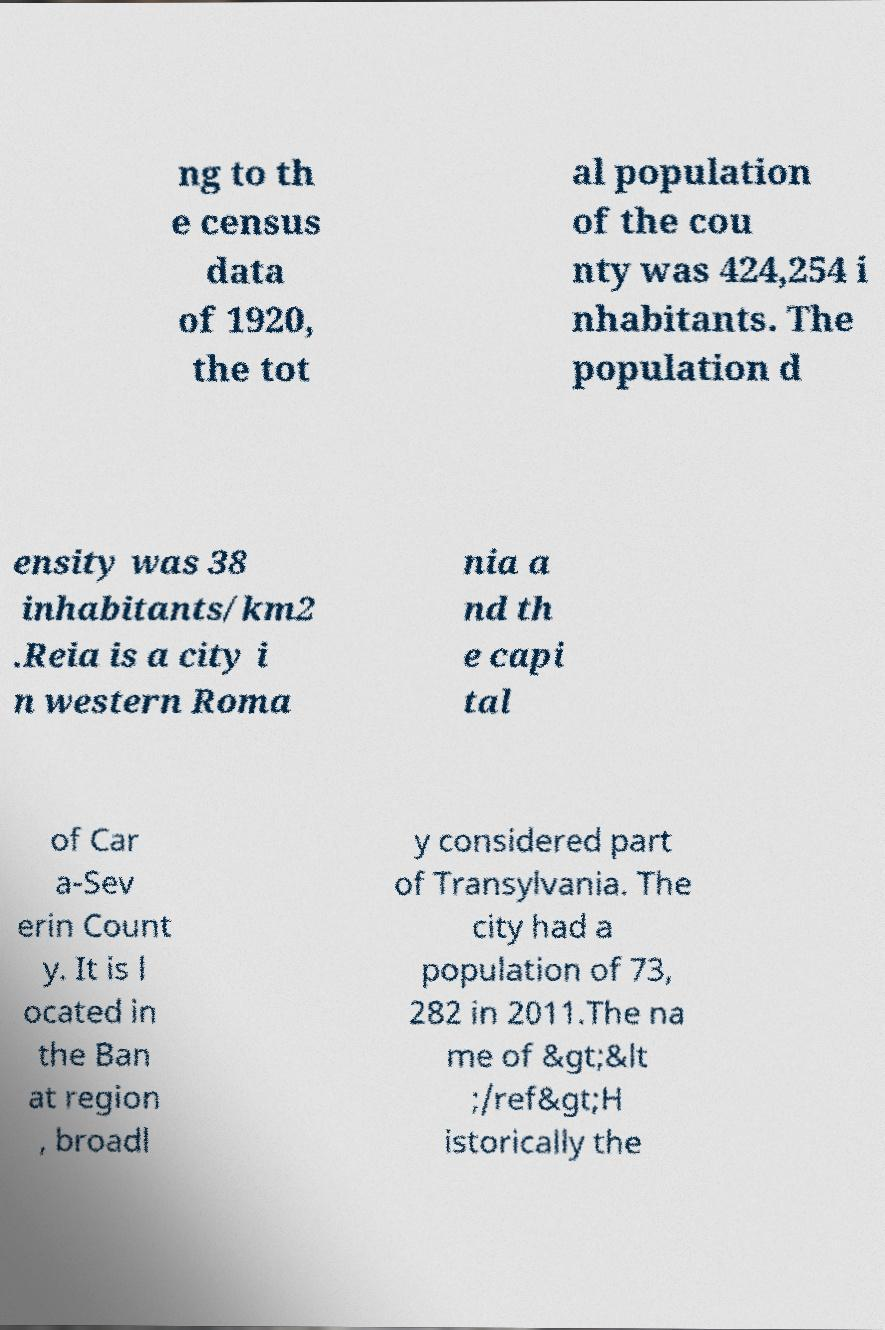Please read and relay the text visible in this image. What does it say? ng to th e census data of 1920, the tot al population of the cou nty was 424,254 i nhabitants. The population d ensity was 38 inhabitants/km2 .Reia is a city i n western Roma nia a nd th e capi tal of Car a-Sev erin Count y. It is l ocated in the Ban at region , broadl y considered part of Transylvania. The city had a population of 73, 282 in 2011.The na me of &gt;&lt ;/ref&gt;H istorically the 